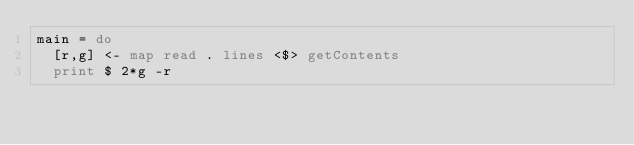Convert code to text. <code><loc_0><loc_0><loc_500><loc_500><_Haskell_>main = do
  [r,g] <- map read . lines <$> getContents
  print $ 2*g -r</code> 